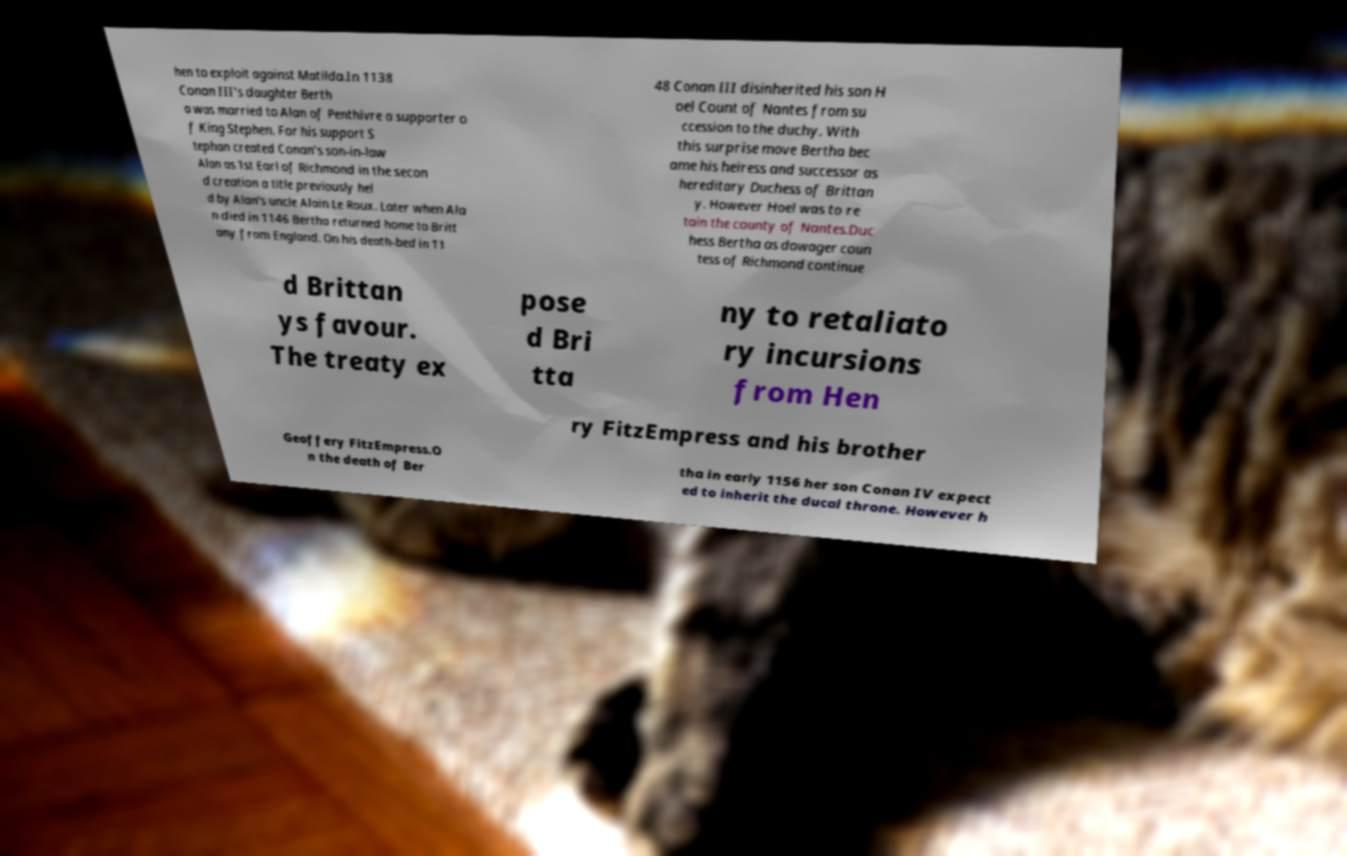I need the written content from this picture converted into text. Can you do that? hen to exploit against Matilda.In 1138 Conan III's daughter Berth a was married to Alan of Penthivre a supporter o f King Stephen. For his support S tephan created Conan's son-in-law Alan as 1st Earl of Richmond in the secon d creation a title previously hel d by Alan's uncle Alain Le Roux. Later when Ala n died in 1146 Bertha returned home to Britt any from England. On his death-bed in 11 48 Conan III disinherited his son H oel Count of Nantes from su ccession to the duchy. With this surprise move Bertha bec ame his heiress and successor as hereditary Duchess of Brittan y. However Hoel was to re tain the county of Nantes.Duc hess Bertha as dowager coun tess of Richmond continue d Brittan ys favour. The treaty ex pose d Bri tta ny to retaliato ry incursions from Hen ry FitzEmpress and his brother Geoffery FitzEmpress.O n the death of Ber tha in early 1156 her son Conan IV expect ed to inherit the ducal throne. However h 